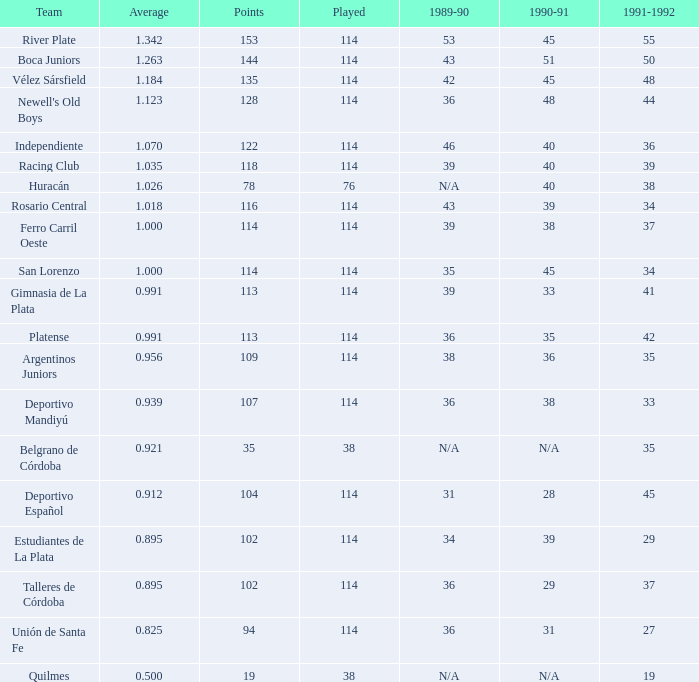What is the average of a 1989-90 season with 36, representing a team of talleres de córdoba, and having played fewer than 114 games? 0.0. 